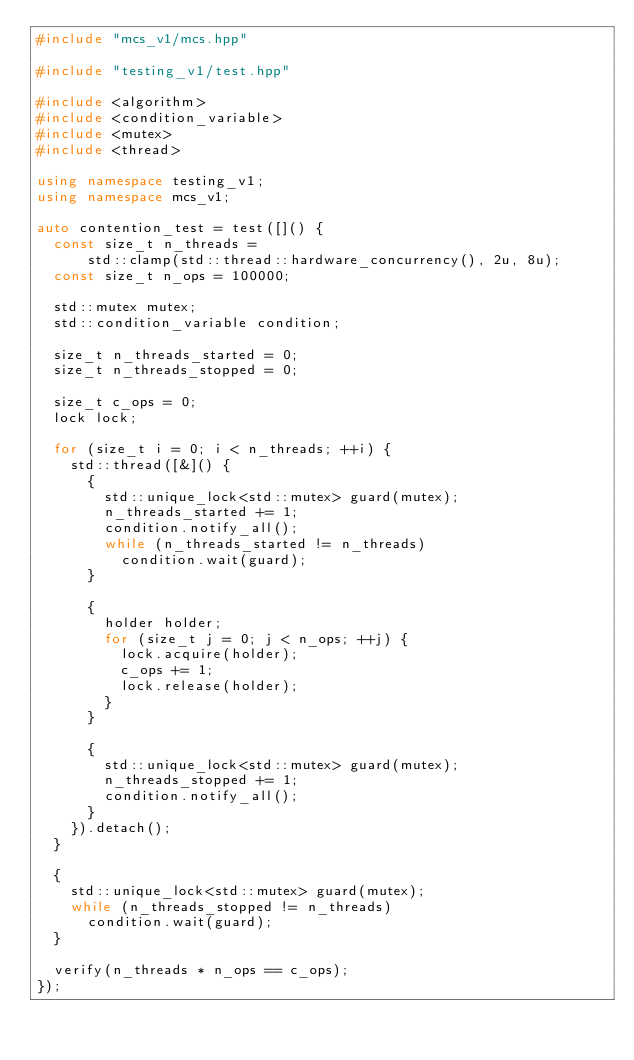Convert code to text. <code><loc_0><loc_0><loc_500><loc_500><_C++_>#include "mcs_v1/mcs.hpp"

#include "testing_v1/test.hpp"

#include <algorithm>
#include <condition_variable>
#include <mutex>
#include <thread>

using namespace testing_v1;
using namespace mcs_v1;

auto contention_test = test([]() {
  const size_t n_threads =
      std::clamp(std::thread::hardware_concurrency(), 2u, 8u);
  const size_t n_ops = 100000;

  std::mutex mutex;
  std::condition_variable condition;

  size_t n_threads_started = 0;
  size_t n_threads_stopped = 0;

  size_t c_ops = 0;
  lock lock;

  for (size_t i = 0; i < n_threads; ++i) {
    std::thread([&]() {
      {
        std::unique_lock<std::mutex> guard(mutex);
        n_threads_started += 1;
        condition.notify_all();
        while (n_threads_started != n_threads)
          condition.wait(guard);
      }

      {
        holder holder;
        for (size_t j = 0; j < n_ops; ++j) {
          lock.acquire(holder);
          c_ops += 1;
          lock.release(holder);
        }
      }

      {
        std::unique_lock<std::mutex> guard(mutex);
        n_threads_stopped += 1;
        condition.notify_all();
      }
    }).detach();
  }

  {
    std::unique_lock<std::mutex> guard(mutex);
    while (n_threads_stopped != n_threads)
      condition.wait(guard);
  }

  verify(n_threads * n_ops == c_ops);
});
</code> 